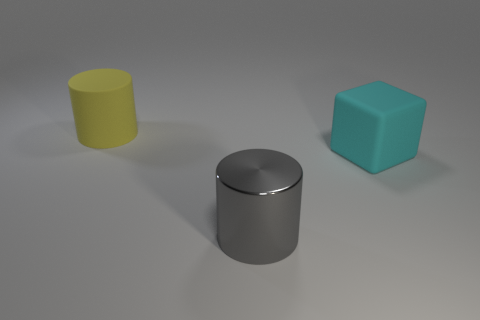There is a matte thing that is in front of the large cylinder behind the metallic thing; what shape is it?
Your answer should be compact. Cube. How many brown objects are either rubber cylinders or big rubber objects?
Provide a short and direct response. 0. There is a rubber object on the right side of the big matte object that is left of the large cyan block; is there a big yellow rubber thing that is in front of it?
Keep it short and to the point. No. Is there any other thing that has the same material as the gray object?
Offer a terse response. No. What number of tiny things are brown rubber cubes or cyan things?
Your response must be concise. 0. Is the shape of the rubber thing behind the cyan object the same as  the gray object?
Give a very brief answer. Yes. Are there fewer big blocks than objects?
Offer a terse response. Yes. Are there any other things that have the same color as the block?
Your response must be concise. No. The large matte thing that is right of the big matte cylinder has what shape?
Keep it short and to the point. Cube. There is a matte block; does it have the same color as the big rubber object that is on the left side of the big gray shiny thing?
Give a very brief answer. No. 